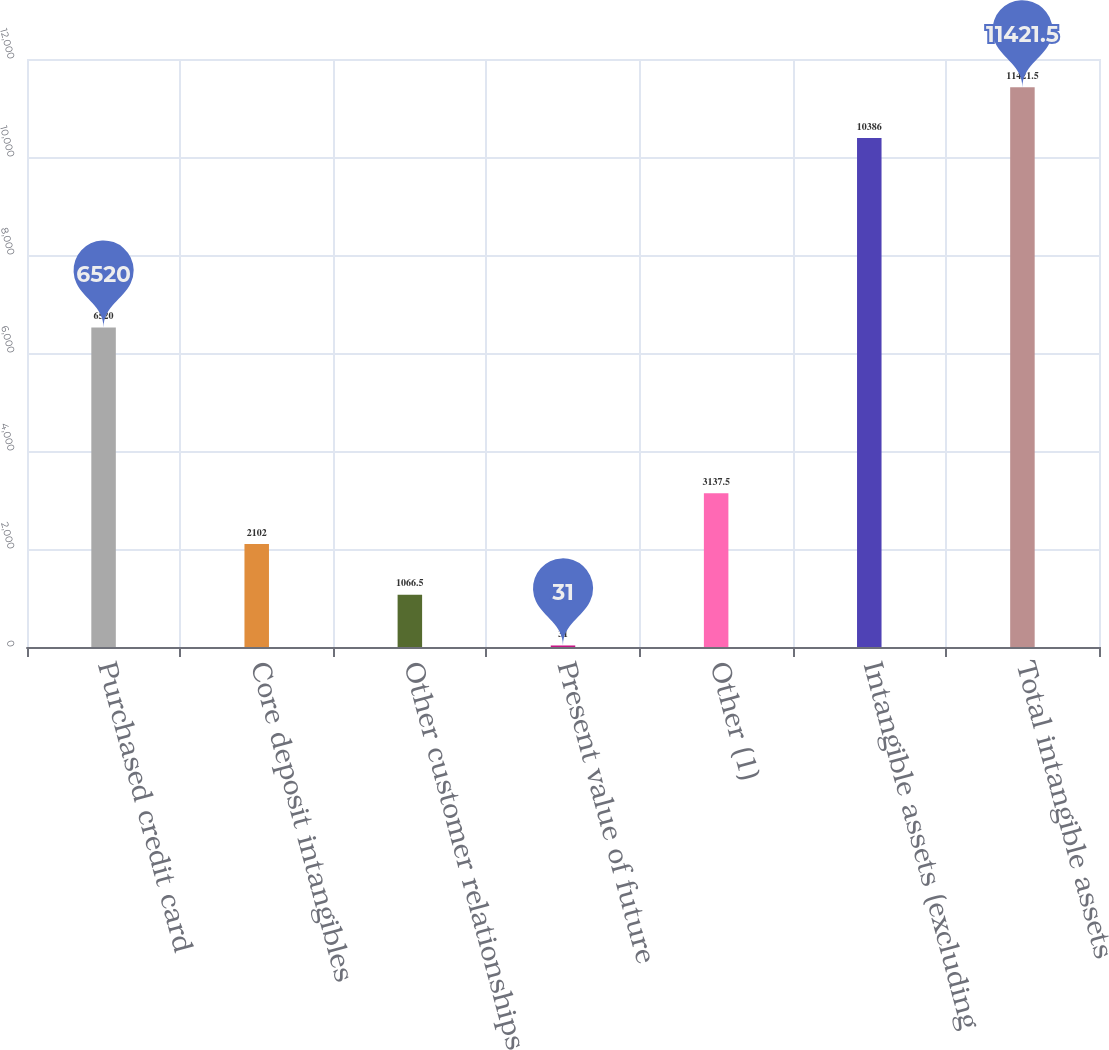<chart> <loc_0><loc_0><loc_500><loc_500><bar_chart><fcel>Purchased credit card<fcel>Core deposit intangibles<fcel>Other customer relationships<fcel>Present value of future<fcel>Other (1)<fcel>Intangible assets (excluding<fcel>Total intangible assets<nl><fcel>6520<fcel>2102<fcel>1066.5<fcel>31<fcel>3137.5<fcel>10386<fcel>11421.5<nl></chart> 